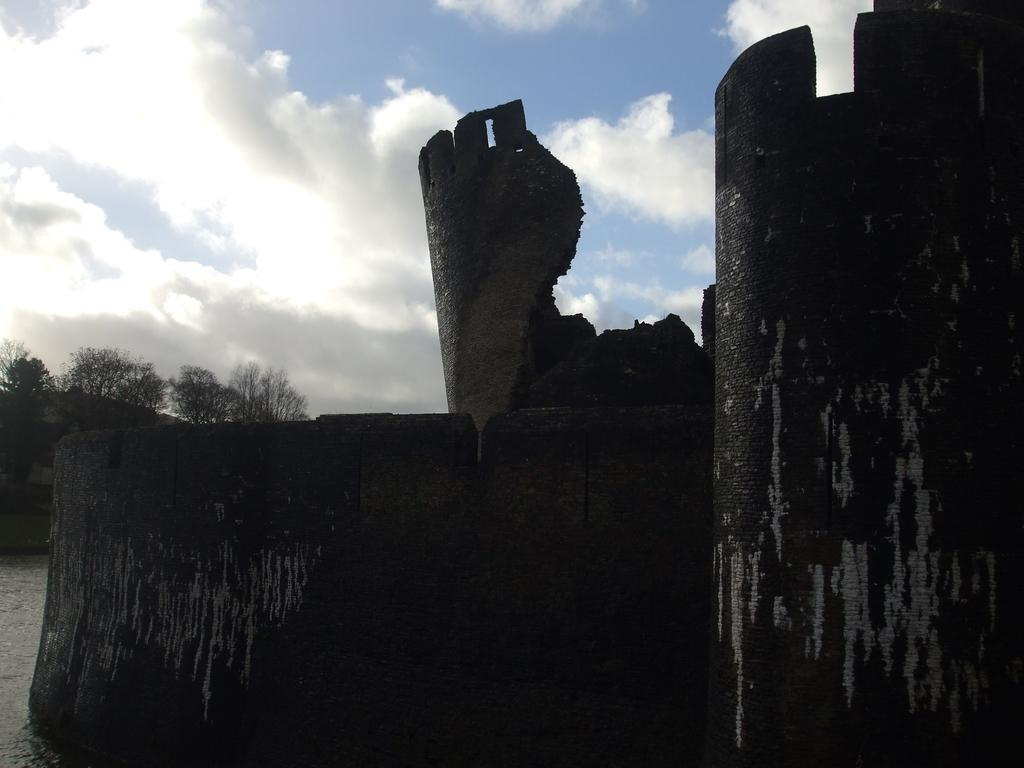What is present at the bottom of the image? There is water at the bottom of the image. What can be seen in the distance in the image? There are mountains and trees in the background of the image. Is there any man-made structure visible in the image? Yes, it appears there is a wall in the right corner of the image. What is visible above the mountains and trees in the image? The sky is visible at the top of the image. Can you touch the horn of the unicorn in the image? There is no unicorn or horn present in the image. What is the range of the telescope in the image? There is no telescope present in the image. 